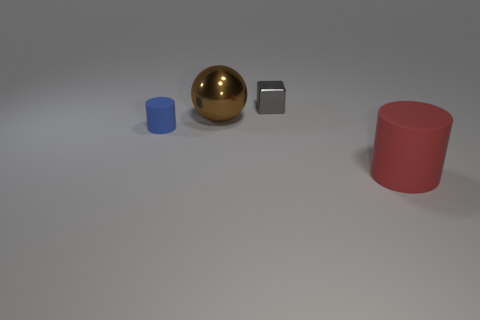Add 4 tiny red rubber things. How many objects exist? 8 Subtract all balls. How many objects are left? 3 Add 1 red rubber cylinders. How many red rubber cylinders exist? 2 Subtract all red cylinders. How many cylinders are left? 1 Subtract 1 blue cylinders. How many objects are left? 3 Subtract 1 spheres. How many spheres are left? 0 Subtract all cyan spheres. Subtract all green blocks. How many spheres are left? 1 Subtract all red cylinders. Subtract all tiny rubber things. How many objects are left? 2 Add 1 small gray blocks. How many small gray blocks are left? 2 